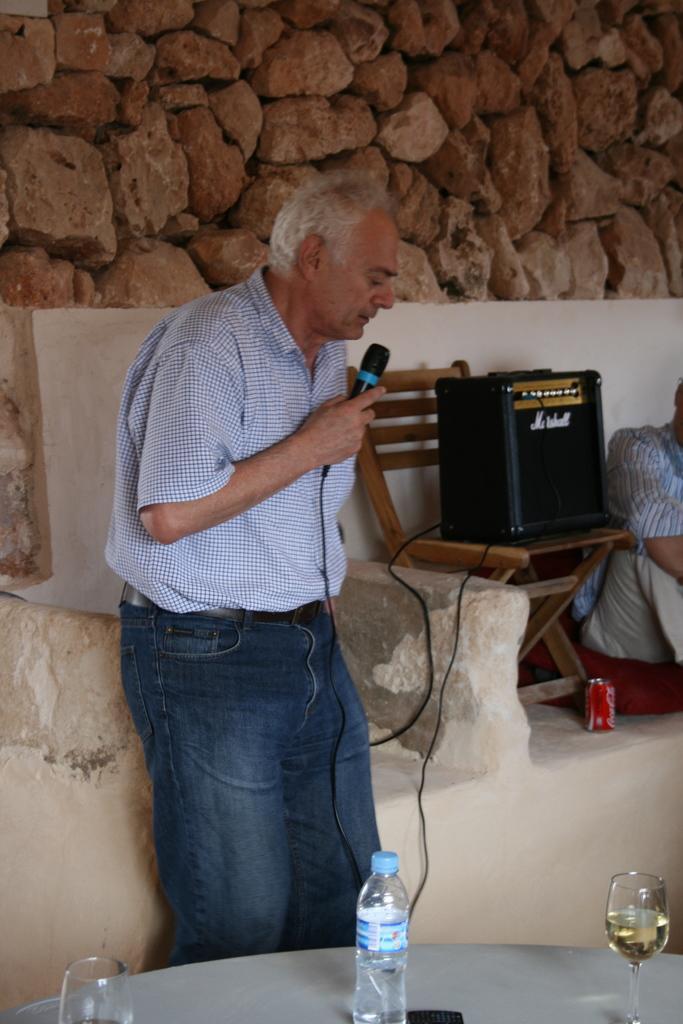How would you summarize this image in a sentence or two? Here we can see a man standing. He is holding a microphone in his right hand and he is speaking. This is a table where a glass and a water bottle is kept on it. This is a chair where a speaker is kept on it. Here we can a man on the right side. 